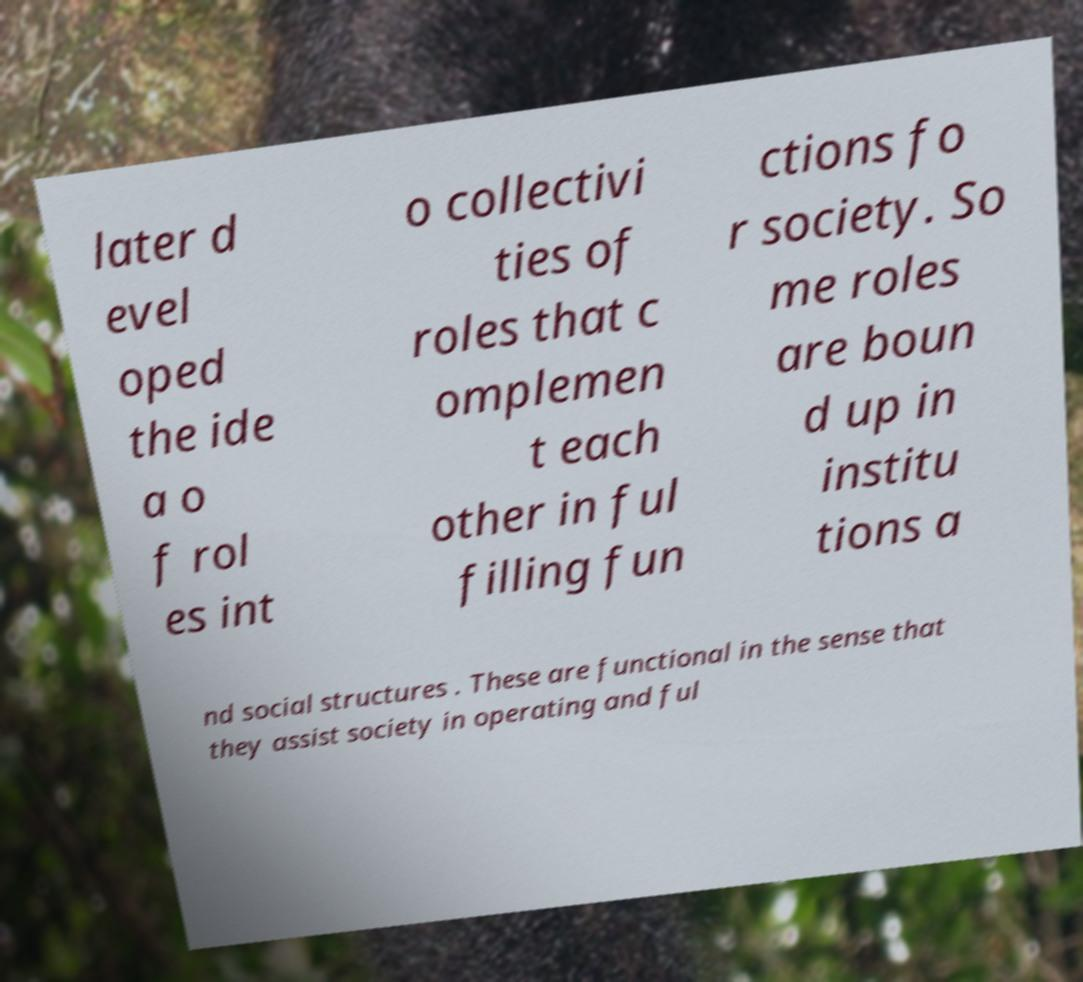Can you read and provide the text displayed in the image?This photo seems to have some interesting text. Can you extract and type it out for me? later d evel oped the ide a o f rol es int o collectivi ties of roles that c omplemen t each other in ful filling fun ctions fo r society. So me roles are boun d up in institu tions a nd social structures . These are functional in the sense that they assist society in operating and ful 